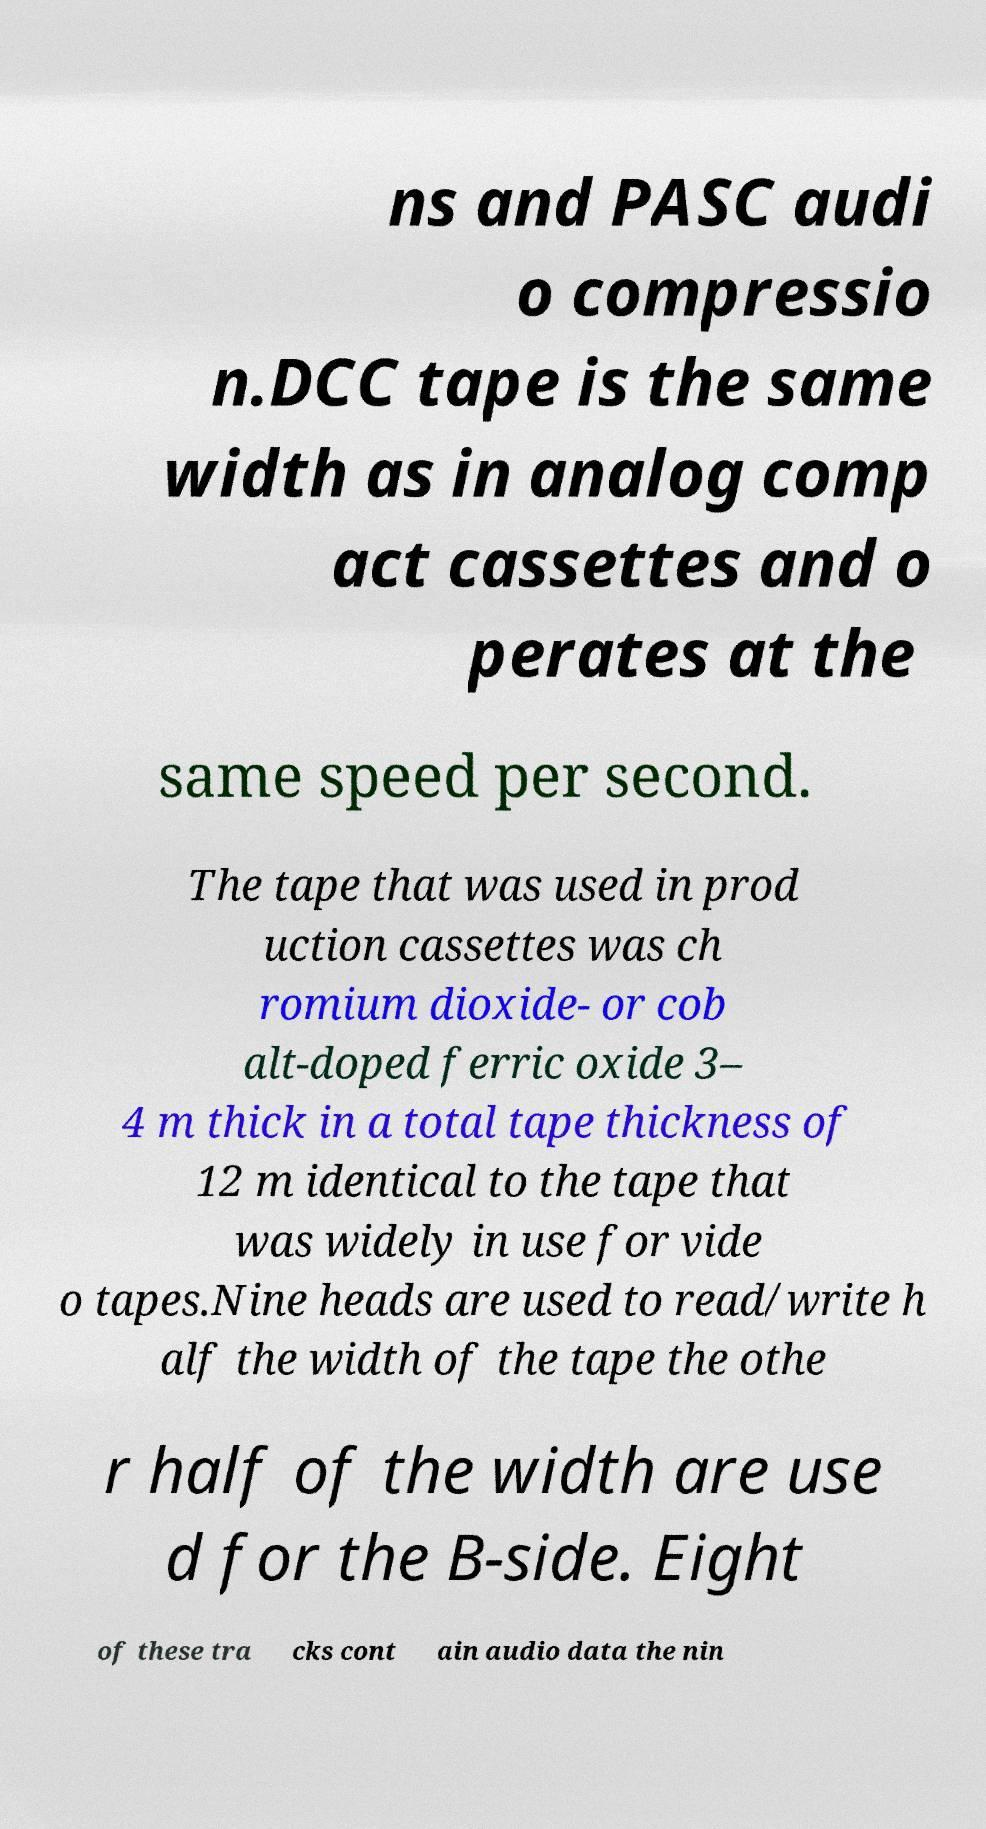For documentation purposes, I need the text within this image transcribed. Could you provide that? ns and PASC audi o compressio n.DCC tape is the same width as in analog comp act cassettes and o perates at the same speed per second. The tape that was used in prod uction cassettes was ch romium dioxide- or cob alt-doped ferric oxide 3– 4 m thick in a total tape thickness of 12 m identical to the tape that was widely in use for vide o tapes.Nine heads are used to read/write h alf the width of the tape the othe r half of the width are use d for the B-side. Eight of these tra cks cont ain audio data the nin 